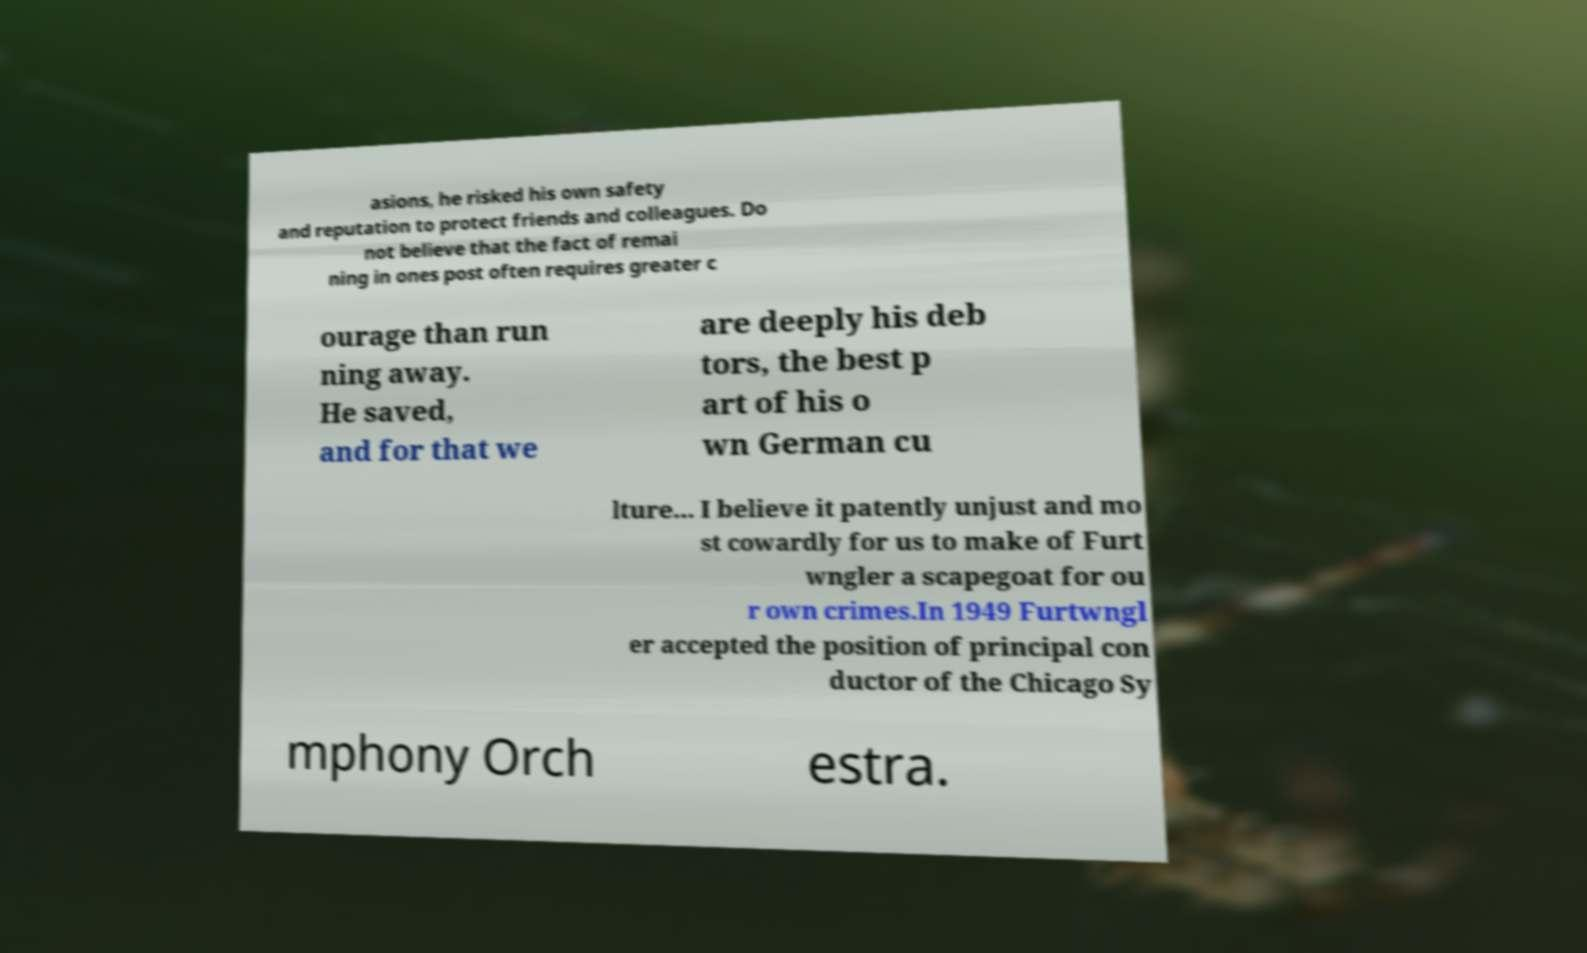What messages or text are displayed in this image? I need them in a readable, typed format. asions, he risked his own safety and reputation to protect friends and colleagues. Do not believe that the fact of remai ning in ones post often requires greater c ourage than run ning away. He saved, and for that we are deeply his deb tors, the best p art of his o wn German cu lture... I believe it patently unjust and mo st cowardly for us to make of Furt wngler a scapegoat for ou r own crimes.In 1949 Furtwngl er accepted the position of principal con ductor of the Chicago Sy mphony Orch estra. 